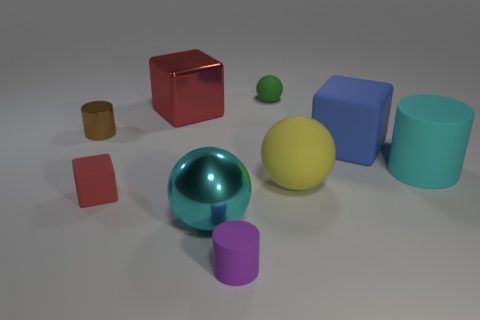Subtract all purple blocks. Subtract all purple cylinders. How many blocks are left? 3 Add 1 blue metallic things. How many objects exist? 10 Subtract all spheres. How many objects are left? 6 Subtract 0 yellow cubes. How many objects are left? 9 Subtract all small red cubes. Subtract all red objects. How many objects are left? 6 Add 7 shiny blocks. How many shiny blocks are left? 8 Add 7 rubber blocks. How many rubber blocks exist? 9 